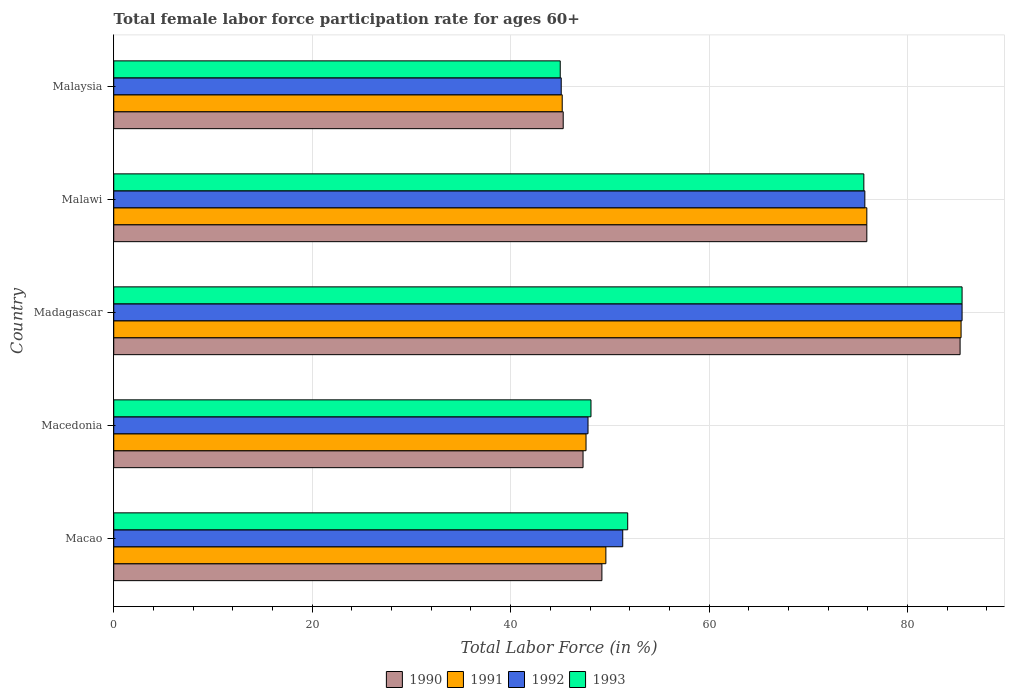How many groups of bars are there?
Your response must be concise. 5. How many bars are there on the 1st tick from the top?
Offer a terse response. 4. What is the label of the 2nd group of bars from the top?
Your answer should be compact. Malawi. In how many cases, is the number of bars for a given country not equal to the number of legend labels?
Provide a short and direct response. 0. What is the female labor force participation rate in 1991 in Malawi?
Provide a succinct answer. 75.9. Across all countries, what is the maximum female labor force participation rate in 1990?
Your answer should be compact. 85.3. Across all countries, what is the minimum female labor force participation rate in 1991?
Your response must be concise. 45.2. In which country was the female labor force participation rate in 1991 maximum?
Offer a terse response. Madagascar. In which country was the female labor force participation rate in 1993 minimum?
Your answer should be very brief. Malaysia. What is the total female labor force participation rate in 1993 in the graph?
Offer a terse response. 306. What is the difference between the female labor force participation rate in 1993 in Macao and that in Malaysia?
Ensure brevity in your answer.  6.8. What is the difference between the female labor force participation rate in 1991 in Macedonia and the female labor force participation rate in 1992 in Madagascar?
Make the answer very short. -37.9. What is the average female labor force participation rate in 1991 per country?
Keep it short and to the point. 60.74. What is the difference between the female labor force participation rate in 1990 and female labor force participation rate in 1993 in Madagascar?
Your response must be concise. -0.2. What is the ratio of the female labor force participation rate in 1992 in Malawi to that in Malaysia?
Your answer should be compact. 1.68. Is the female labor force participation rate in 1990 in Macao less than that in Malaysia?
Keep it short and to the point. No. Is the difference between the female labor force participation rate in 1990 in Macao and Malawi greater than the difference between the female labor force participation rate in 1993 in Macao and Malawi?
Ensure brevity in your answer.  No. What is the difference between the highest and the second highest female labor force participation rate in 1993?
Make the answer very short. 9.9. What is the difference between the highest and the lowest female labor force participation rate in 1992?
Provide a short and direct response. 40.4. Is the sum of the female labor force participation rate in 1990 in Macedonia and Malawi greater than the maximum female labor force participation rate in 1991 across all countries?
Keep it short and to the point. Yes. Is it the case that in every country, the sum of the female labor force participation rate in 1992 and female labor force participation rate in 1993 is greater than the sum of female labor force participation rate in 1991 and female labor force participation rate in 1990?
Give a very brief answer. No. What does the 3rd bar from the top in Madagascar represents?
Make the answer very short. 1991. What does the 2nd bar from the bottom in Madagascar represents?
Ensure brevity in your answer.  1991. Are all the bars in the graph horizontal?
Offer a very short reply. Yes. How many countries are there in the graph?
Your response must be concise. 5. What is the difference between two consecutive major ticks on the X-axis?
Make the answer very short. 20. Does the graph contain any zero values?
Ensure brevity in your answer.  No. Does the graph contain grids?
Your answer should be very brief. Yes. Where does the legend appear in the graph?
Give a very brief answer. Bottom center. How are the legend labels stacked?
Offer a very short reply. Horizontal. What is the title of the graph?
Provide a short and direct response. Total female labor force participation rate for ages 60+. What is the Total Labor Force (in %) in 1990 in Macao?
Ensure brevity in your answer.  49.2. What is the Total Labor Force (in %) of 1991 in Macao?
Ensure brevity in your answer.  49.6. What is the Total Labor Force (in %) of 1992 in Macao?
Keep it short and to the point. 51.3. What is the Total Labor Force (in %) in 1993 in Macao?
Ensure brevity in your answer.  51.8. What is the Total Labor Force (in %) in 1990 in Macedonia?
Make the answer very short. 47.3. What is the Total Labor Force (in %) in 1991 in Macedonia?
Your answer should be compact. 47.6. What is the Total Labor Force (in %) of 1992 in Macedonia?
Ensure brevity in your answer.  47.8. What is the Total Labor Force (in %) in 1993 in Macedonia?
Your answer should be very brief. 48.1. What is the Total Labor Force (in %) in 1990 in Madagascar?
Offer a terse response. 85.3. What is the Total Labor Force (in %) of 1991 in Madagascar?
Offer a very short reply. 85.4. What is the Total Labor Force (in %) in 1992 in Madagascar?
Your response must be concise. 85.5. What is the Total Labor Force (in %) of 1993 in Madagascar?
Give a very brief answer. 85.5. What is the Total Labor Force (in %) of 1990 in Malawi?
Offer a very short reply. 75.9. What is the Total Labor Force (in %) in 1991 in Malawi?
Provide a short and direct response. 75.9. What is the Total Labor Force (in %) in 1992 in Malawi?
Your answer should be compact. 75.7. What is the Total Labor Force (in %) of 1993 in Malawi?
Offer a terse response. 75.6. What is the Total Labor Force (in %) in 1990 in Malaysia?
Give a very brief answer. 45.3. What is the Total Labor Force (in %) of 1991 in Malaysia?
Your response must be concise. 45.2. What is the Total Labor Force (in %) in 1992 in Malaysia?
Provide a succinct answer. 45.1. Across all countries, what is the maximum Total Labor Force (in %) of 1990?
Provide a succinct answer. 85.3. Across all countries, what is the maximum Total Labor Force (in %) in 1991?
Provide a short and direct response. 85.4. Across all countries, what is the maximum Total Labor Force (in %) in 1992?
Your answer should be compact. 85.5. Across all countries, what is the maximum Total Labor Force (in %) of 1993?
Your response must be concise. 85.5. Across all countries, what is the minimum Total Labor Force (in %) in 1990?
Offer a terse response. 45.3. Across all countries, what is the minimum Total Labor Force (in %) of 1991?
Provide a succinct answer. 45.2. Across all countries, what is the minimum Total Labor Force (in %) of 1992?
Keep it short and to the point. 45.1. Across all countries, what is the minimum Total Labor Force (in %) in 1993?
Give a very brief answer. 45. What is the total Total Labor Force (in %) of 1990 in the graph?
Make the answer very short. 303. What is the total Total Labor Force (in %) of 1991 in the graph?
Provide a succinct answer. 303.7. What is the total Total Labor Force (in %) of 1992 in the graph?
Offer a very short reply. 305.4. What is the total Total Labor Force (in %) of 1993 in the graph?
Give a very brief answer. 306. What is the difference between the Total Labor Force (in %) of 1991 in Macao and that in Macedonia?
Offer a terse response. 2. What is the difference between the Total Labor Force (in %) of 1993 in Macao and that in Macedonia?
Your response must be concise. 3.7. What is the difference between the Total Labor Force (in %) in 1990 in Macao and that in Madagascar?
Offer a terse response. -36.1. What is the difference between the Total Labor Force (in %) in 1991 in Macao and that in Madagascar?
Keep it short and to the point. -35.8. What is the difference between the Total Labor Force (in %) of 1992 in Macao and that in Madagascar?
Provide a short and direct response. -34.2. What is the difference between the Total Labor Force (in %) of 1993 in Macao and that in Madagascar?
Make the answer very short. -33.7. What is the difference between the Total Labor Force (in %) in 1990 in Macao and that in Malawi?
Your answer should be very brief. -26.7. What is the difference between the Total Labor Force (in %) in 1991 in Macao and that in Malawi?
Offer a very short reply. -26.3. What is the difference between the Total Labor Force (in %) in 1992 in Macao and that in Malawi?
Your response must be concise. -24.4. What is the difference between the Total Labor Force (in %) in 1993 in Macao and that in Malawi?
Provide a short and direct response. -23.8. What is the difference between the Total Labor Force (in %) of 1990 in Macao and that in Malaysia?
Keep it short and to the point. 3.9. What is the difference between the Total Labor Force (in %) in 1991 in Macao and that in Malaysia?
Offer a very short reply. 4.4. What is the difference between the Total Labor Force (in %) of 1992 in Macao and that in Malaysia?
Provide a short and direct response. 6.2. What is the difference between the Total Labor Force (in %) of 1993 in Macao and that in Malaysia?
Keep it short and to the point. 6.8. What is the difference between the Total Labor Force (in %) of 1990 in Macedonia and that in Madagascar?
Keep it short and to the point. -38. What is the difference between the Total Labor Force (in %) in 1991 in Macedonia and that in Madagascar?
Make the answer very short. -37.8. What is the difference between the Total Labor Force (in %) of 1992 in Macedonia and that in Madagascar?
Your answer should be very brief. -37.7. What is the difference between the Total Labor Force (in %) in 1993 in Macedonia and that in Madagascar?
Your response must be concise. -37.4. What is the difference between the Total Labor Force (in %) in 1990 in Macedonia and that in Malawi?
Give a very brief answer. -28.6. What is the difference between the Total Labor Force (in %) in 1991 in Macedonia and that in Malawi?
Keep it short and to the point. -28.3. What is the difference between the Total Labor Force (in %) in 1992 in Macedonia and that in Malawi?
Your answer should be compact. -27.9. What is the difference between the Total Labor Force (in %) of 1993 in Macedonia and that in Malawi?
Offer a very short reply. -27.5. What is the difference between the Total Labor Force (in %) in 1990 in Macedonia and that in Malaysia?
Keep it short and to the point. 2. What is the difference between the Total Labor Force (in %) of 1992 in Macedonia and that in Malaysia?
Offer a very short reply. 2.7. What is the difference between the Total Labor Force (in %) in 1992 in Madagascar and that in Malawi?
Offer a terse response. 9.8. What is the difference between the Total Labor Force (in %) of 1993 in Madagascar and that in Malawi?
Your response must be concise. 9.9. What is the difference between the Total Labor Force (in %) of 1991 in Madagascar and that in Malaysia?
Your response must be concise. 40.2. What is the difference between the Total Labor Force (in %) in 1992 in Madagascar and that in Malaysia?
Offer a very short reply. 40.4. What is the difference between the Total Labor Force (in %) in 1993 in Madagascar and that in Malaysia?
Give a very brief answer. 40.5. What is the difference between the Total Labor Force (in %) of 1990 in Malawi and that in Malaysia?
Give a very brief answer. 30.6. What is the difference between the Total Labor Force (in %) of 1991 in Malawi and that in Malaysia?
Your answer should be very brief. 30.7. What is the difference between the Total Labor Force (in %) in 1992 in Malawi and that in Malaysia?
Your answer should be compact. 30.6. What is the difference between the Total Labor Force (in %) in 1993 in Malawi and that in Malaysia?
Give a very brief answer. 30.6. What is the difference between the Total Labor Force (in %) of 1990 in Macao and the Total Labor Force (in %) of 1992 in Macedonia?
Provide a succinct answer. 1.4. What is the difference between the Total Labor Force (in %) of 1991 in Macao and the Total Labor Force (in %) of 1993 in Macedonia?
Make the answer very short. 1.5. What is the difference between the Total Labor Force (in %) of 1992 in Macao and the Total Labor Force (in %) of 1993 in Macedonia?
Your response must be concise. 3.2. What is the difference between the Total Labor Force (in %) in 1990 in Macao and the Total Labor Force (in %) in 1991 in Madagascar?
Your answer should be compact. -36.2. What is the difference between the Total Labor Force (in %) in 1990 in Macao and the Total Labor Force (in %) in 1992 in Madagascar?
Offer a terse response. -36.3. What is the difference between the Total Labor Force (in %) of 1990 in Macao and the Total Labor Force (in %) of 1993 in Madagascar?
Offer a terse response. -36.3. What is the difference between the Total Labor Force (in %) in 1991 in Macao and the Total Labor Force (in %) in 1992 in Madagascar?
Give a very brief answer. -35.9. What is the difference between the Total Labor Force (in %) of 1991 in Macao and the Total Labor Force (in %) of 1993 in Madagascar?
Make the answer very short. -35.9. What is the difference between the Total Labor Force (in %) in 1992 in Macao and the Total Labor Force (in %) in 1993 in Madagascar?
Make the answer very short. -34.2. What is the difference between the Total Labor Force (in %) of 1990 in Macao and the Total Labor Force (in %) of 1991 in Malawi?
Offer a terse response. -26.7. What is the difference between the Total Labor Force (in %) in 1990 in Macao and the Total Labor Force (in %) in 1992 in Malawi?
Your response must be concise. -26.5. What is the difference between the Total Labor Force (in %) in 1990 in Macao and the Total Labor Force (in %) in 1993 in Malawi?
Your answer should be compact. -26.4. What is the difference between the Total Labor Force (in %) in 1991 in Macao and the Total Labor Force (in %) in 1992 in Malawi?
Offer a terse response. -26.1. What is the difference between the Total Labor Force (in %) of 1992 in Macao and the Total Labor Force (in %) of 1993 in Malawi?
Make the answer very short. -24.3. What is the difference between the Total Labor Force (in %) in 1990 in Macao and the Total Labor Force (in %) in 1991 in Malaysia?
Make the answer very short. 4. What is the difference between the Total Labor Force (in %) of 1990 in Macao and the Total Labor Force (in %) of 1993 in Malaysia?
Ensure brevity in your answer.  4.2. What is the difference between the Total Labor Force (in %) in 1991 in Macao and the Total Labor Force (in %) in 1992 in Malaysia?
Offer a very short reply. 4.5. What is the difference between the Total Labor Force (in %) of 1991 in Macao and the Total Labor Force (in %) of 1993 in Malaysia?
Provide a short and direct response. 4.6. What is the difference between the Total Labor Force (in %) in 1990 in Macedonia and the Total Labor Force (in %) in 1991 in Madagascar?
Offer a terse response. -38.1. What is the difference between the Total Labor Force (in %) of 1990 in Macedonia and the Total Labor Force (in %) of 1992 in Madagascar?
Your answer should be compact. -38.2. What is the difference between the Total Labor Force (in %) in 1990 in Macedonia and the Total Labor Force (in %) in 1993 in Madagascar?
Offer a very short reply. -38.2. What is the difference between the Total Labor Force (in %) in 1991 in Macedonia and the Total Labor Force (in %) in 1992 in Madagascar?
Your answer should be very brief. -37.9. What is the difference between the Total Labor Force (in %) in 1991 in Macedonia and the Total Labor Force (in %) in 1993 in Madagascar?
Provide a short and direct response. -37.9. What is the difference between the Total Labor Force (in %) in 1992 in Macedonia and the Total Labor Force (in %) in 1993 in Madagascar?
Make the answer very short. -37.7. What is the difference between the Total Labor Force (in %) in 1990 in Macedonia and the Total Labor Force (in %) in 1991 in Malawi?
Your response must be concise. -28.6. What is the difference between the Total Labor Force (in %) of 1990 in Macedonia and the Total Labor Force (in %) of 1992 in Malawi?
Ensure brevity in your answer.  -28.4. What is the difference between the Total Labor Force (in %) of 1990 in Macedonia and the Total Labor Force (in %) of 1993 in Malawi?
Make the answer very short. -28.3. What is the difference between the Total Labor Force (in %) of 1991 in Macedonia and the Total Labor Force (in %) of 1992 in Malawi?
Your response must be concise. -28.1. What is the difference between the Total Labor Force (in %) of 1991 in Macedonia and the Total Labor Force (in %) of 1993 in Malawi?
Ensure brevity in your answer.  -28. What is the difference between the Total Labor Force (in %) of 1992 in Macedonia and the Total Labor Force (in %) of 1993 in Malawi?
Provide a succinct answer. -27.8. What is the difference between the Total Labor Force (in %) in 1990 in Macedonia and the Total Labor Force (in %) in 1991 in Malaysia?
Keep it short and to the point. 2.1. What is the difference between the Total Labor Force (in %) in 1991 in Macedonia and the Total Labor Force (in %) in 1992 in Malaysia?
Offer a very short reply. 2.5. What is the difference between the Total Labor Force (in %) in 1992 in Macedonia and the Total Labor Force (in %) in 1993 in Malaysia?
Your response must be concise. 2.8. What is the difference between the Total Labor Force (in %) in 1990 in Madagascar and the Total Labor Force (in %) in 1992 in Malawi?
Your answer should be very brief. 9.6. What is the difference between the Total Labor Force (in %) in 1991 in Madagascar and the Total Labor Force (in %) in 1992 in Malawi?
Provide a succinct answer. 9.7. What is the difference between the Total Labor Force (in %) in 1992 in Madagascar and the Total Labor Force (in %) in 1993 in Malawi?
Provide a short and direct response. 9.9. What is the difference between the Total Labor Force (in %) of 1990 in Madagascar and the Total Labor Force (in %) of 1991 in Malaysia?
Your answer should be very brief. 40.1. What is the difference between the Total Labor Force (in %) of 1990 in Madagascar and the Total Labor Force (in %) of 1992 in Malaysia?
Give a very brief answer. 40.2. What is the difference between the Total Labor Force (in %) in 1990 in Madagascar and the Total Labor Force (in %) in 1993 in Malaysia?
Your response must be concise. 40.3. What is the difference between the Total Labor Force (in %) of 1991 in Madagascar and the Total Labor Force (in %) of 1992 in Malaysia?
Ensure brevity in your answer.  40.3. What is the difference between the Total Labor Force (in %) in 1991 in Madagascar and the Total Labor Force (in %) in 1993 in Malaysia?
Provide a short and direct response. 40.4. What is the difference between the Total Labor Force (in %) in 1992 in Madagascar and the Total Labor Force (in %) in 1993 in Malaysia?
Your answer should be very brief. 40.5. What is the difference between the Total Labor Force (in %) of 1990 in Malawi and the Total Labor Force (in %) of 1991 in Malaysia?
Provide a short and direct response. 30.7. What is the difference between the Total Labor Force (in %) of 1990 in Malawi and the Total Labor Force (in %) of 1992 in Malaysia?
Your answer should be very brief. 30.8. What is the difference between the Total Labor Force (in %) in 1990 in Malawi and the Total Labor Force (in %) in 1993 in Malaysia?
Provide a succinct answer. 30.9. What is the difference between the Total Labor Force (in %) of 1991 in Malawi and the Total Labor Force (in %) of 1992 in Malaysia?
Offer a very short reply. 30.8. What is the difference between the Total Labor Force (in %) in 1991 in Malawi and the Total Labor Force (in %) in 1993 in Malaysia?
Provide a short and direct response. 30.9. What is the difference between the Total Labor Force (in %) of 1992 in Malawi and the Total Labor Force (in %) of 1993 in Malaysia?
Provide a succinct answer. 30.7. What is the average Total Labor Force (in %) in 1990 per country?
Offer a terse response. 60.6. What is the average Total Labor Force (in %) in 1991 per country?
Give a very brief answer. 60.74. What is the average Total Labor Force (in %) in 1992 per country?
Your answer should be compact. 61.08. What is the average Total Labor Force (in %) of 1993 per country?
Your answer should be compact. 61.2. What is the difference between the Total Labor Force (in %) in 1990 and Total Labor Force (in %) in 1992 in Macao?
Give a very brief answer. -2.1. What is the difference between the Total Labor Force (in %) of 1990 and Total Labor Force (in %) of 1993 in Macao?
Ensure brevity in your answer.  -2.6. What is the difference between the Total Labor Force (in %) in 1992 and Total Labor Force (in %) in 1993 in Macao?
Provide a succinct answer. -0.5. What is the difference between the Total Labor Force (in %) in 1990 and Total Labor Force (in %) in 1991 in Macedonia?
Make the answer very short. -0.3. What is the difference between the Total Labor Force (in %) in 1990 and Total Labor Force (in %) in 1992 in Macedonia?
Keep it short and to the point. -0.5. What is the difference between the Total Labor Force (in %) of 1991 and Total Labor Force (in %) of 1992 in Macedonia?
Offer a terse response. -0.2. What is the difference between the Total Labor Force (in %) in 1991 and Total Labor Force (in %) in 1993 in Macedonia?
Provide a succinct answer. -0.5. What is the difference between the Total Labor Force (in %) in 1991 and Total Labor Force (in %) in 1992 in Madagascar?
Provide a short and direct response. -0.1. What is the difference between the Total Labor Force (in %) in 1991 and Total Labor Force (in %) in 1993 in Madagascar?
Your answer should be compact. -0.1. What is the difference between the Total Labor Force (in %) of 1990 and Total Labor Force (in %) of 1992 in Malawi?
Your answer should be very brief. 0.2. What is the difference between the Total Labor Force (in %) of 1992 and Total Labor Force (in %) of 1993 in Malawi?
Offer a very short reply. 0.1. What is the difference between the Total Labor Force (in %) in 1990 and Total Labor Force (in %) in 1991 in Malaysia?
Keep it short and to the point. 0.1. What is the difference between the Total Labor Force (in %) in 1990 and Total Labor Force (in %) in 1992 in Malaysia?
Offer a very short reply. 0.2. What is the difference between the Total Labor Force (in %) in 1991 and Total Labor Force (in %) in 1993 in Malaysia?
Offer a terse response. 0.2. What is the ratio of the Total Labor Force (in %) in 1990 in Macao to that in Macedonia?
Your response must be concise. 1.04. What is the ratio of the Total Labor Force (in %) in 1991 in Macao to that in Macedonia?
Make the answer very short. 1.04. What is the ratio of the Total Labor Force (in %) in 1992 in Macao to that in Macedonia?
Ensure brevity in your answer.  1.07. What is the ratio of the Total Labor Force (in %) in 1990 in Macao to that in Madagascar?
Your answer should be compact. 0.58. What is the ratio of the Total Labor Force (in %) of 1991 in Macao to that in Madagascar?
Make the answer very short. 0.58. What is the ratio of the Total Labor Force (in %) in 1993 in Macao to that in Madagascar?
Provide a short and direct response. 0.61. What is the ratio of the Total Labor Force (in %) in 1990 in Macao to that in Malawi?
Your answer should be compact. 0.65. What is the ratio of the Total Labor Force (in %) of 1991 in Macao to that in Malawi?
Your answer should be very brief. 0.65. What is the ratio of the Total Labor Force (in %) of 1992 in Macao to that in Malawi?
Keep it short and to the point. 0.68. What is the ratio of the Total Labor Force (in %) of 1993 in Macao to that in Malawi?
Offer a terse response. 0.69. What is the ratio of the Total Labor Force (in %) in 1990 in Macao to that in Malaysia?
Offer a terse response. 1.09. What is the ratio of the Total Labor Force (in %) in 1991 in Macao to that in Malaysia?
Your answer should be compact. 1.1. What is the ratio of the Total Labor Force (in %) of 1992 in Macao to that in Malaysia?
Your answer should be compact. 1.14. What is the ratio of the Total Labor Force (in %) in 1993 in Macao to that in Malaysia?
Provide a succinct answer. 1.15. What is the ratio of the Total Labor Force (in %) in 1990 in Macedonia to that in Madagascar?
Offer a very short reply. 0.55. What is the ratio of the Total Labor Force (in %) of 1991 in Macedonia to that in Madagascar?
Ensure brevity in your answer.  0.56. What is the ratio of the Total Labor Force (in %) in 1992 in Macedonia to that in Madagascar?
Offer a terse response. 0.56. What is the ratio of the Total Labor Force (in %) of 1993 in Macedonia to that in Madagascar?
Your answer should be compact. 0.56. What is the ratio of the Total Labor Force (in %) in 1990 in Macedonia to that in Malawi?
Ensure brevity in your answer.  0.62. What is the ratio of the Total Labor Force (in %) in 1991 in Macedonia to that in Malawi?
Offer a very short reply. 0.63. What is the ratio of the Total Labor Force (in %) of 1992 in Macedonia to that in Malawi?
Keep it short and to the point. 0.63. What is the ratio of the Total Labor Force (in %) in 1993 in Macedonia to that in Malawi?
Make the answer very short. 0.64. What is the ratio of the Total Labor Force (in %) of 1990 in Macedonia to that in Malaysia?
Keep it short and to the point. 1.04. What is the ratio of the Total Labor Force (in %) of 1991 in Macedonia to that in Malaysia?
Your answer should be very brief. 1.05. What is the ratio of the Total Labor Force (in %) of 1992 in Macedonia to that in Malaysia?
Make the answer very short. 1.06. What is the ratio of the Total Labor Force (in %) of 1993 in Macedonia to that in Malaysia?
Make the answer very short. 1.07. What is the ratio of the Total Labor Force (in %) of 1990 in Madagascar to that in Malawi?
Give a very brief answer. 1.12. What is the ratio of the Total Labor Force (in %) in 1991 in Madagascar to that in Malawi?
Offer a very short reply. 1.13. What is the ratio of the Total Labor Force (in %) of 1992 in Madagascar to that in Malawi?
Offer a terse response. 1.13. What is the ratio of the Total Labor Force (in %) in 1993 in Madagascar to that in Malawi?
Keep it short and to the point. 1.13. What is the ratio of the Total Labor Force (in %) in 1990 in Madagascar to that in Malaysia?
Provide a succinct answer. 1.88. What is the ratio of the Total Labor Force (in %) in 1991 in Madagascar to that in Malaysia?
Provide a succinct answer. 1.89. What is the ratio of the Total Labor Force (in %) of 1992 in Madagascar to that in Malaysia?
Ensure brevity in your answer.  1.9. What is the ratio of the Total Labor Force (in %) in 1990 in Malawi to that in Malaysia?
Ensure brevity in your answer.  1.68. What is the ratio of the Total Labor Force (in %) in 1991 in Malawi to that in Malaysia?
Your answer should be very brief. 1.68. What is the ratio of the Total Labor Force (in %) of 1992 in Malawi to that in Malaysia?
Your answer should be very brief. 1.68. What is the ratio of the Total Labor Force (in %) in 1993 in Malawi to that in Malaysia?
Your answer should be compact. 1.68. What is the difference between the highest and the second highest Total Labor Force (in %) of 1990?
Offer a very short reply. 9.4. What is the difference between the highest and the second highest Total Labor Force (in %) in 1991?
Your response must be concise. 9.5. What is the difference between the highest and the second highest Total Labor Force (in %) of 1992?
Keep it short and to the point. 9.8. What is the difference between the highest and the lowest Total Labor Force (in %) in 1990?
Your response must be concise. 40. What is the difference between the highest and the lowest Total Labor Force (in %) of 1991?
Offer a terse response. 40.2. What is the difference between the highest and the lowest Total Labor Force (in %) of 1992?
Keep it short and to the point. 40.4. What is the difference between the highest and the lowest Total Labor Force (in %) of 1993?
Provide a succinct answer. 40.5. 